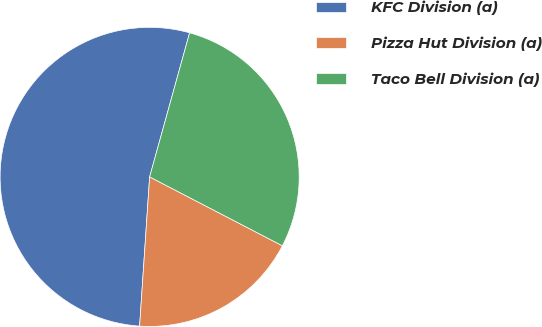Convert chart to OTSL. <chart><loc_0><loc_0><loc_500><loc_500><pie_chart><fcel>KFC Division (a)<fcel>Pizza Hut Division (a)<fcel>Taco Bell Division (a)<nl><fcel>53.24%<fcel>18.45%<fcel>28.31%<nl></chart> 